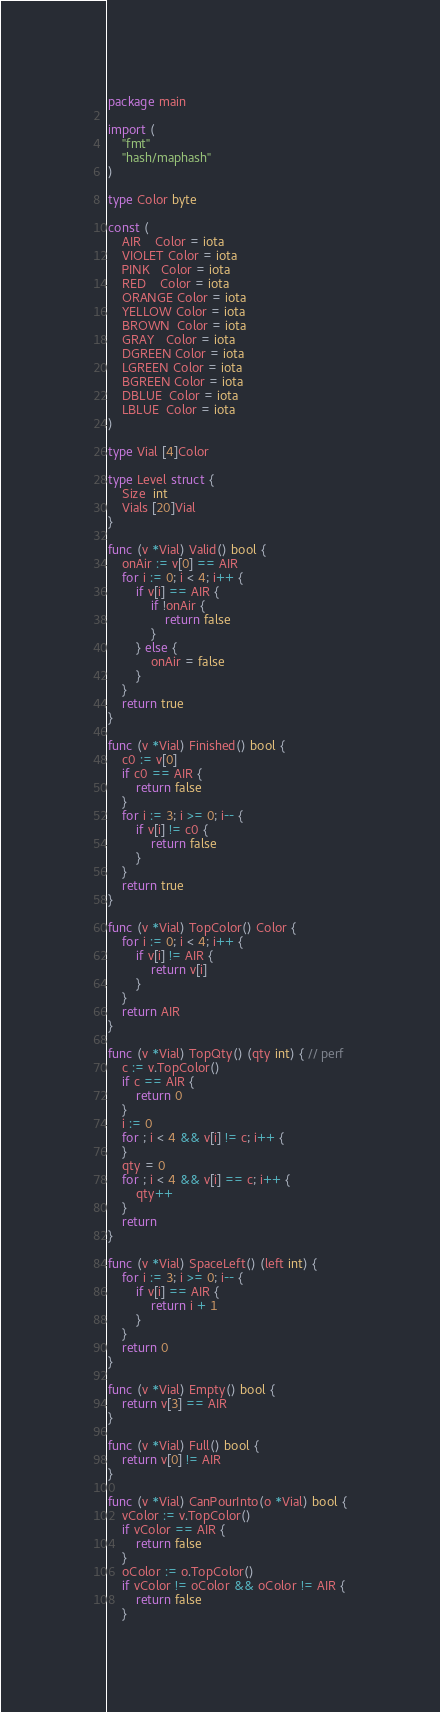Convert code to text. <code><loc_0><loc_0><loc_500><loc_500><_Go_>package main

import (
	"fmt"
	"hash/maphash"
)

type Color byte

const (
	AIR    Color = iota
	VIOLET Color = iota
	PINK   Color = iota
	RED    Color = iota
	ORANGE Color = iota
	YELLOW Color = iota
	BROWN  Color = iota
	GRAY   Color = iota
	DGREEN Color = iota
	LGREEN Color = iota
	BGREEN Color = iota
	DBLUE  Color = iota
	LBLUE  Color = iota
)

type Vial [4]Color

type Level struct {
	Size  int
	Vials [20]Vial
}

func (v *Vial) Valid() bool {
	onAir := v[0] == AIR
	for i := 0; i < 4; i++ {
		if v[i] == AIR {
			if !onAir {
				return false
			}
		} else {
			onAir = false
		}
	}
	return true
}

func (v *Vial) Finished() bool {
	c0 := v[0]
	if c0 == AIR {
		return false
	}
	for i := 3; i >= 0; i-- {
		if v[i] != c0 {
			return false
		}
	}
	return true
}

func (v *Vial) TopColor() Color {
	for i := 0; i < 4; i++ {
		if v[i] != AIR {
			return v[i]
		}
	}
	return AIR
}

func (v *Vial) TopQty() (qty int) { // perf
	c := v.TopColor()
	if c == AIR {
		return 0
	}
	i := 0
	for ; i < 4 && v[i] != c; i++ {
	}
	qty = 0
	for ; i < 4 && v[i] == c; i++ {
		qty++
	}
	return
}

func (v *Vial) SpaceLeft() (left int) {
	for i := 3; i >= 0; i-- {
		if v[i] == AIR {
			return i + 1
		}
	}
	return 0
}

func (v *Vial) Empty() bool {
	return v[3] == AIR
}

func (v *Vial) Full() bool {
	return v[0] != AIR
}

func (v *Vial) CanPourInto(o *Vial) bool {
	vColor := v.TopColor()
	if vColor == AIR {
		return false
	}
	oColor := o.TopColor()
	if vColor != oColor && oColor != AIR {
		return false
	}</code> 